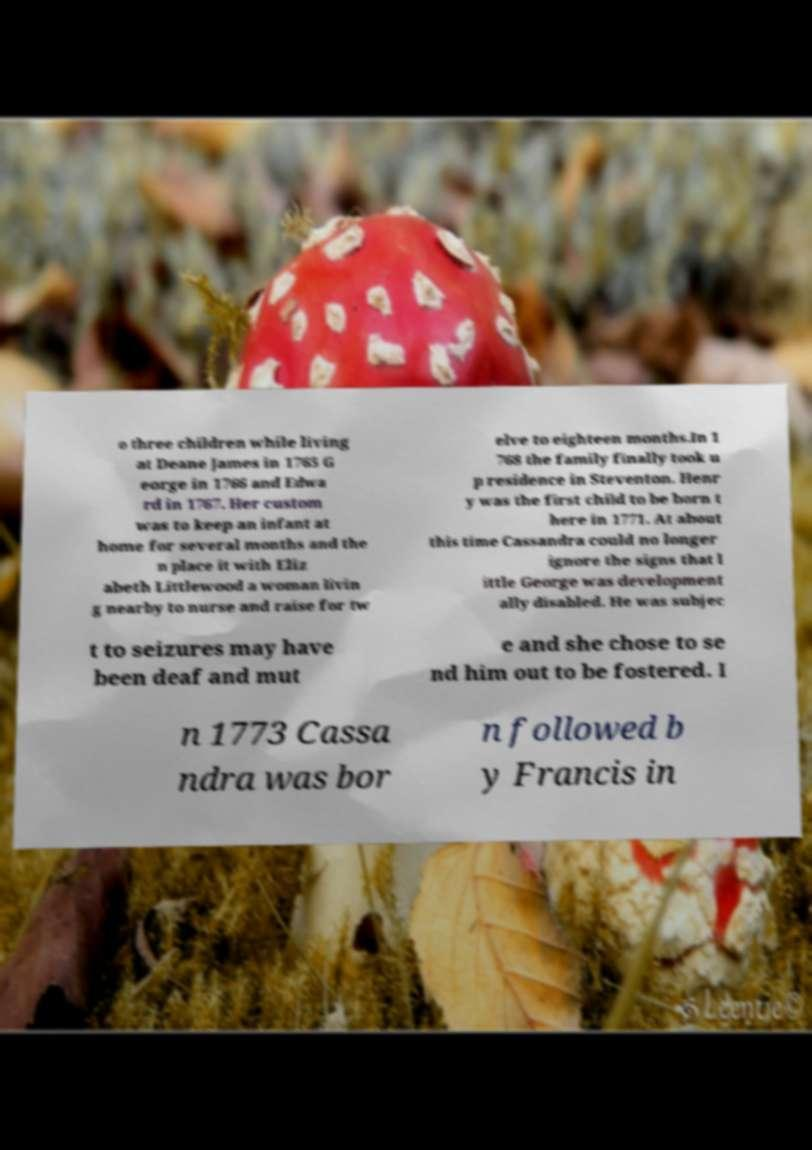Please identify and transcribe the text found in this image. o three children while living at Deane James in 1765 G eorge in 1766 and Edwa rd in 1767. Her custom was to keep an infant at home for several months and the n place it with Eliz abeth Littlewood a woman livin g nearby to nurse and raise for tw elve to eighteen months.In 1 768 the family finally took u p residence in Steventon. Henr y was the first child to be born t here in 1771. At about this time Cassandra could no longer ignore the signs that l ittle George was development ally disabled. He was subjec t to seizures may have been deaf and mut e and she chose to se nd him out to be fostered. I n 1773 Cassa ndra was bor n followed b y Francis in 